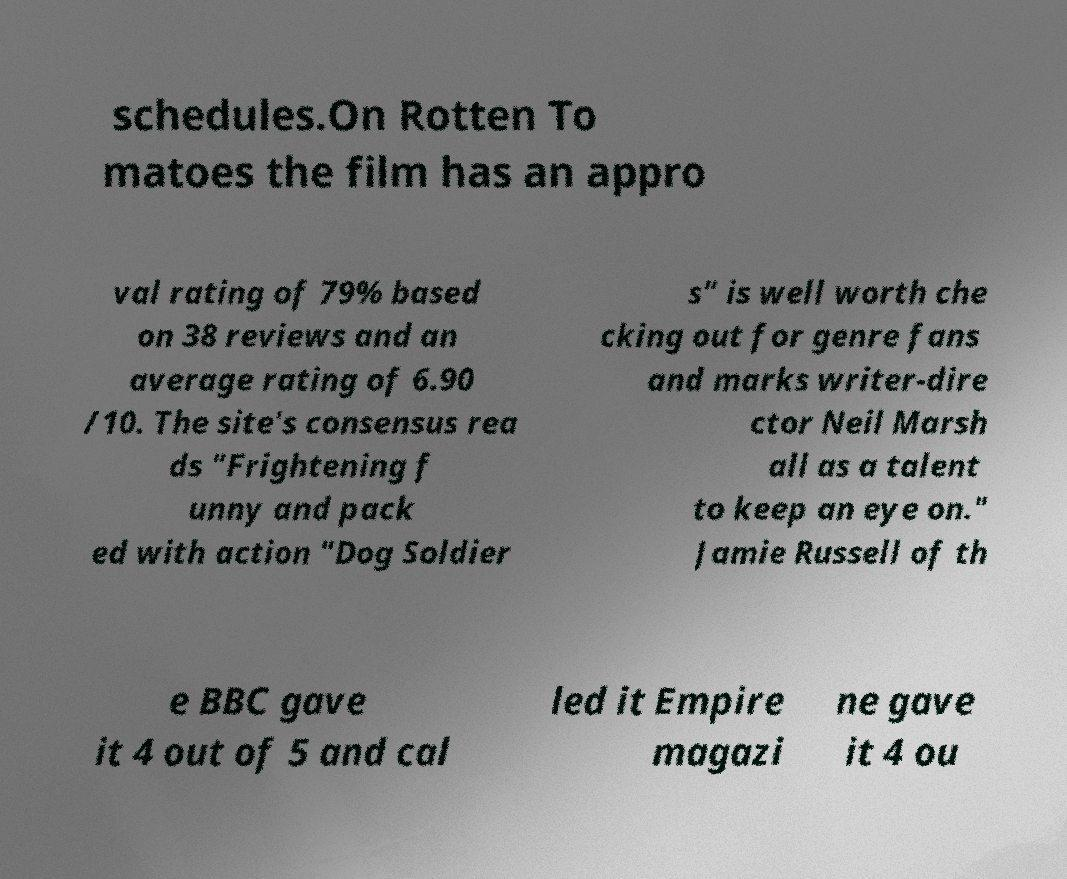Could you assist in decoding the text presented in this image and type it out clearly? schedules.On Rotten To matoes the film has an appro val rating of 79% based on 38 reviews and an average rating of 6.90 /10. The site's consensus rea ds "Frightening f unny and pack ed with action "Dog Soldier s" is well worth che cking out for genre fans and marks writer-dire ctor Neil Marsh all as a talent to keep an eye on." Jamie Russell of th e BBC gave it 4 out of 5 and cal led it Empire magazi ne gave it 4 ou 